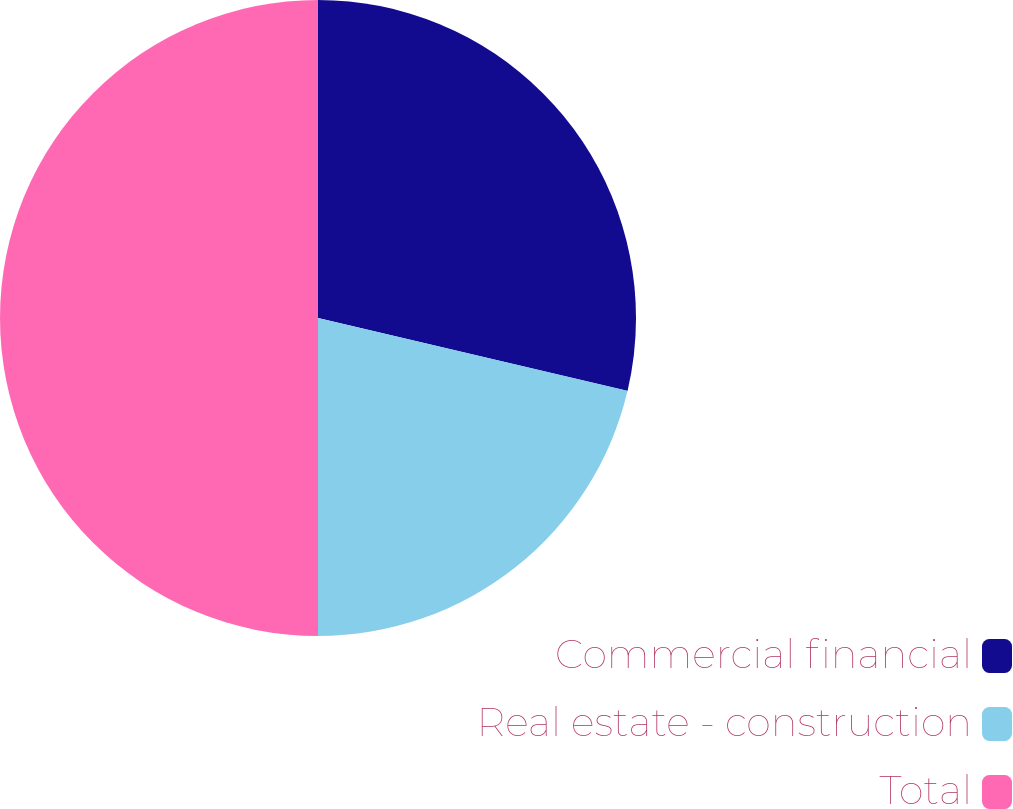<chart> <loc_0><loc_0><loc_500><loc_500><pie_chart><fcel>Commercial financial<fcel>Real estate - construction<fcel>Total<nl><fcel>28.68%<fcel>21.32%<fcel>50.0%<nl></chart> 